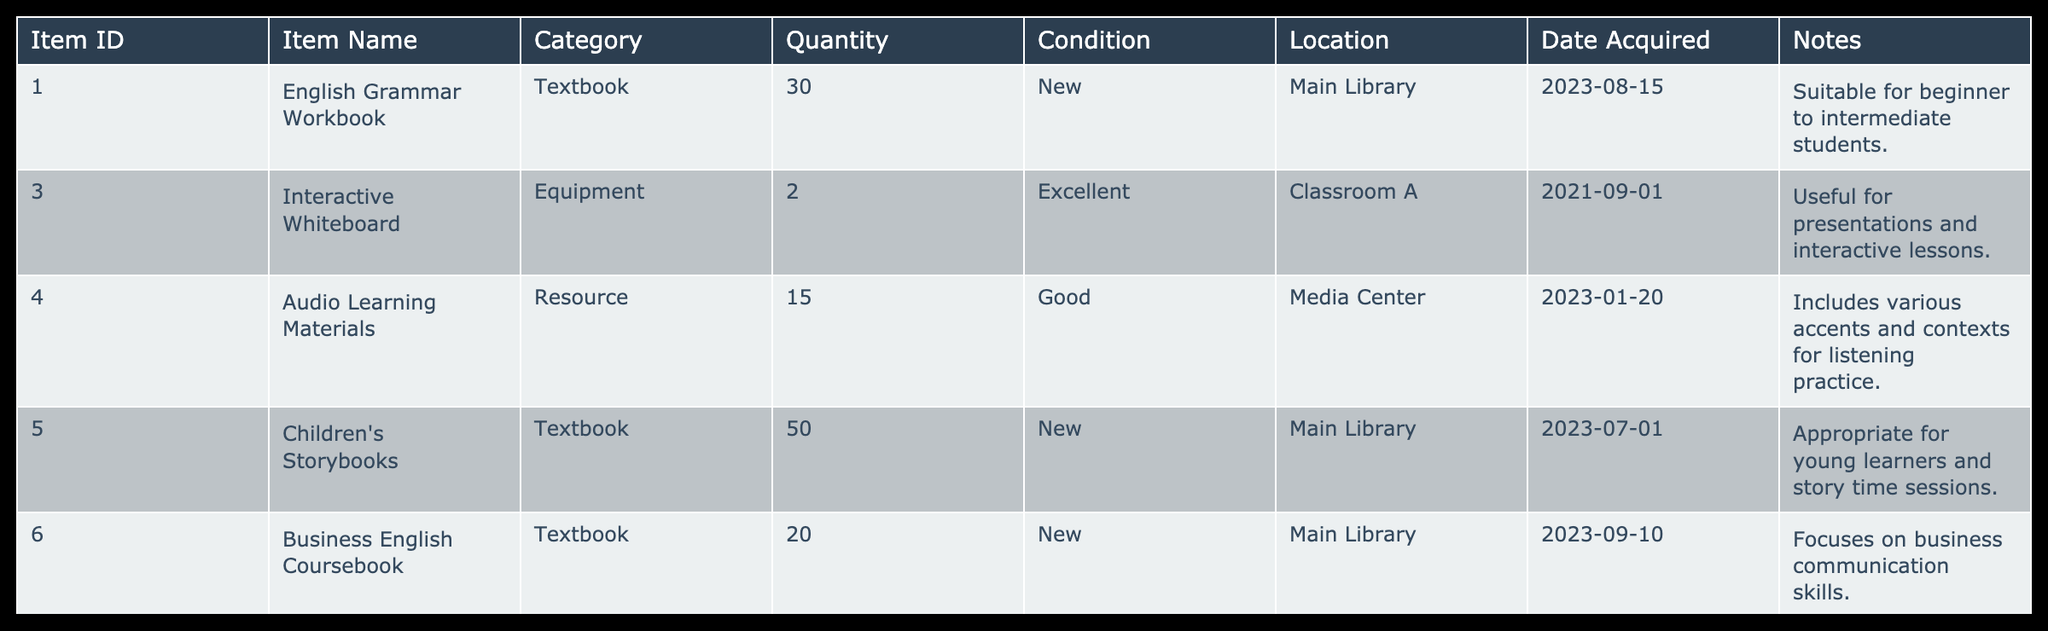What is the quantity of the "English Grammar Workbook"? The table shows the row for "English Grammar Workbook," where the quantity is directly listed under the Quantity column. It shows a quantity of 30.
Answer: 30 How many total "Textbook" items are there in the inventory? By looking at the Category column, we identify the "Textbook" entries: "English Grammar Workbook," "Children's Storybooks," "Business English Coursebook," and "Pronunciation Guidebook," totaling 4 textbooks.
Answer: 4 Are there any items in "New" condition? Checking the Condition column, we find "English Grammar Workbook," "Children's Storybooks," and "Business English Coursebook," all listed as "New," indicating that there are items in new condition.
Answer: Yes What is the total quantity of "Resource" items available? The Resource items in the table are "Audio Learning Materials" (15) and "Assessment Test Kits" (5). Adding these gives: 15 + 5 = 20. Thus, the total quantity of Resource items is 20.
Answer: 20 Which item has the most quantity? Examining the Quantity column, "Children's Storybooks" has the highest quantity of 50. We confirm by referring to the other entries that none exceed this value.
Answer: Children's Storybooks How many DVD items are in "Good" condition? The table shows "Cultural Immersion DVDs" in the Media category, which is categorized as "Good." Checking the quantity, it lists 10. Therefore, the total for DVD items in good condition is 10.
Answer: 10 What is the average quantity of items per category? The total quantity of items across all categories is 30 + 2 + 15 + 50 + 20 + 10 + 5 + 15 = 147, and there are 7 unique categories. Therefore, the average is 147 / 7 = 21.
Answer: 21 Is there any "Assessment Test Kits" that is categorized as "New"? Looking at the table, "Assessment Test Kits" have a quantity of 5 but are listed as "Good" in terms of condition. Thus, there are no Assessment Test Kits in a "New" condition.
Answer: No What is the difference in quantities between the highest and lowest quantities of items? The highest quantity is from "Children's Storybooks" (50) and the lowest is "Assessment Test Kits" (5). The difference is 50 - 5 = 45.
Answer: 45 